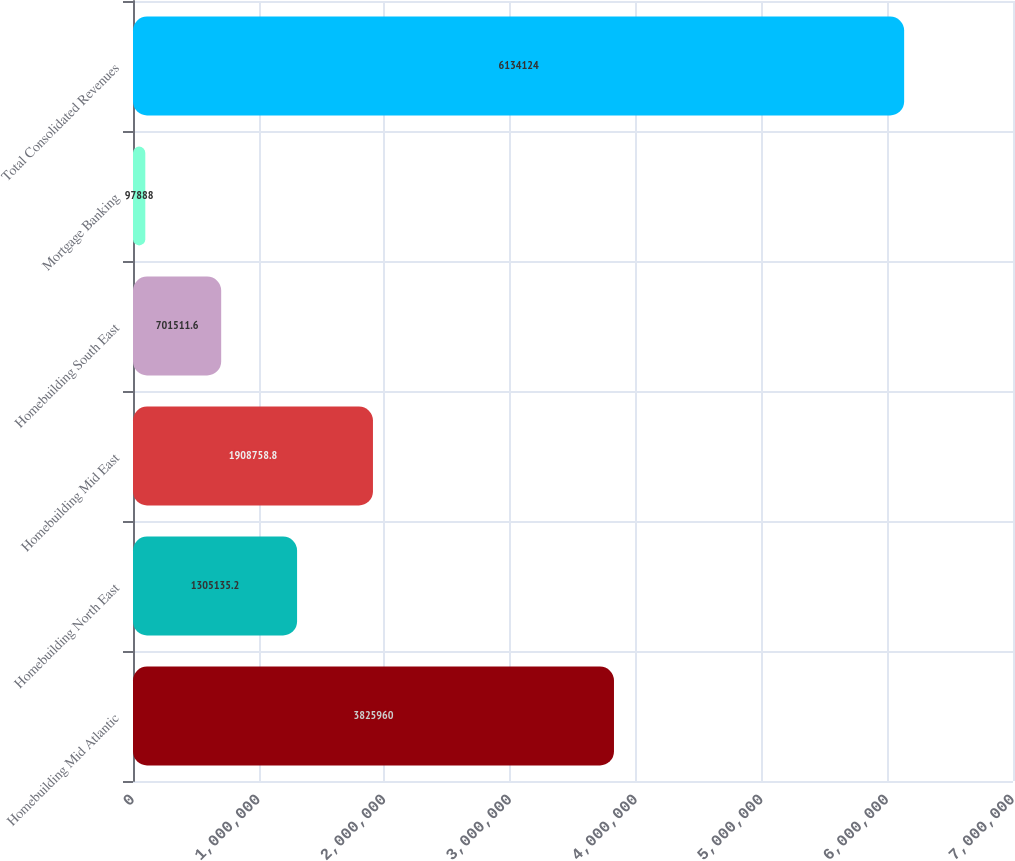<chart> <loc_0><loc_0><loc_500><loc_500><bar_chart><fcel>Homebuilding Mid Atlantic<fcel>Homebuilding North East<fcel>Homebuilding Mid East<fcel>Homebuilding South East<fcel>Mortgage Banking<fcel>Total Consolidated Revenues<nl><fcel>3.82596e+06<fcel>1.30514e+06<fcel>1.90876e+06<fcel>701512<fcel>97888<fcel>6.13412e+06<nl></chart> 